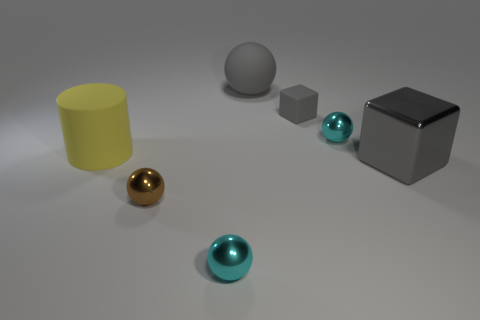Add 2 tiny brown rubber blocks. How many objects exist? 9 Subtract all spheres. How many objects are left? 3 Subtract all blue matte spheres. Subtract all big matte objects. How many objects are left? 5 Add 1 tiny rubber things. How many tiny rubber things are left? 2 Add 7 big metallic cylinders. How many big metallic cylinders exist? 7 Subtract 0 green spheres. How many objects are left? 7 